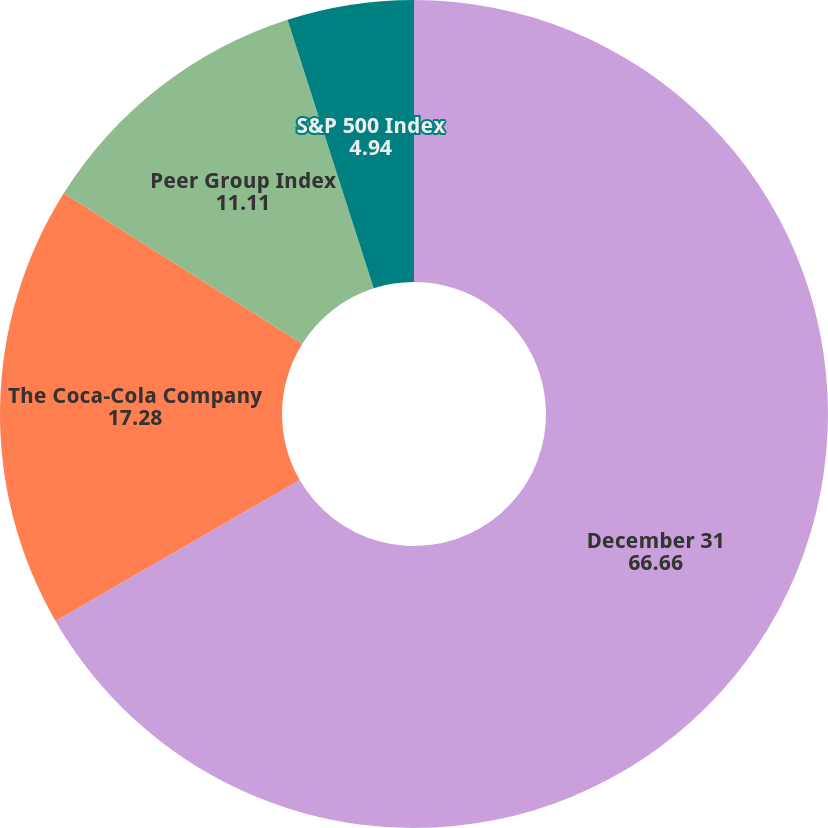Convert chart. <chart><loc_0><loc_0><loc_500><loc_500><pie_chart><fcel>December 31<fcel>The Coca-Cola Company<fcel>Peer Group Index<fcel>S&P 500 Index<nl><fcel>66.66%<fcel>17.28%<fcel>11.11%<fcel>4.94%<nl></chart> 